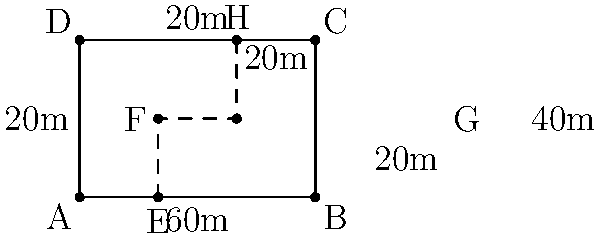A rectangular construction site measures 60m by 40m. An L-shaped exclusion zone within the site occupies the top-right corner, measuring 40m by 20m on one side and 20m by 20m on the other. How many meters of fencing are required to secure the entire perimeter of the construction site, including the exclusion zone? To find the total fencing required, we need to calculate the perimeter of the entire site and add the length of the inner boundary of the exclusion zone.

Step 1: Calculate the perimeter of the entire site
$$\text{Perimeter} = 2 \times (\text{length} + \text{width})$$
$$\text{Perimeter} = 2 \times (60\text{m} + 40\text{m}) = 2 \times 100\text{m} = 200\text{m}$$

Step 2: Calculate the length of the inner boundary of the exclusion zone
The inner boundary consists of two segments:
- Vertical segment: 20m
- Horizontal segment: 40m
$$\text{Inner boundary} = 20\text{m} + 40\text{m} = 60\text{m}$$

Step 3: Sum up the total fencing required
$$\text{Total fencing} = \text{Perimeter} + \text{Inner boundary}$$
$$\text{Total fencing} = 200\text{m} + 60\text{m} = 260\text{m}$$

Therefore, 260 meters of fencing are required to secure the entire perimeter of the construction site, including the exclusion zone.
Answer: 260 meters 